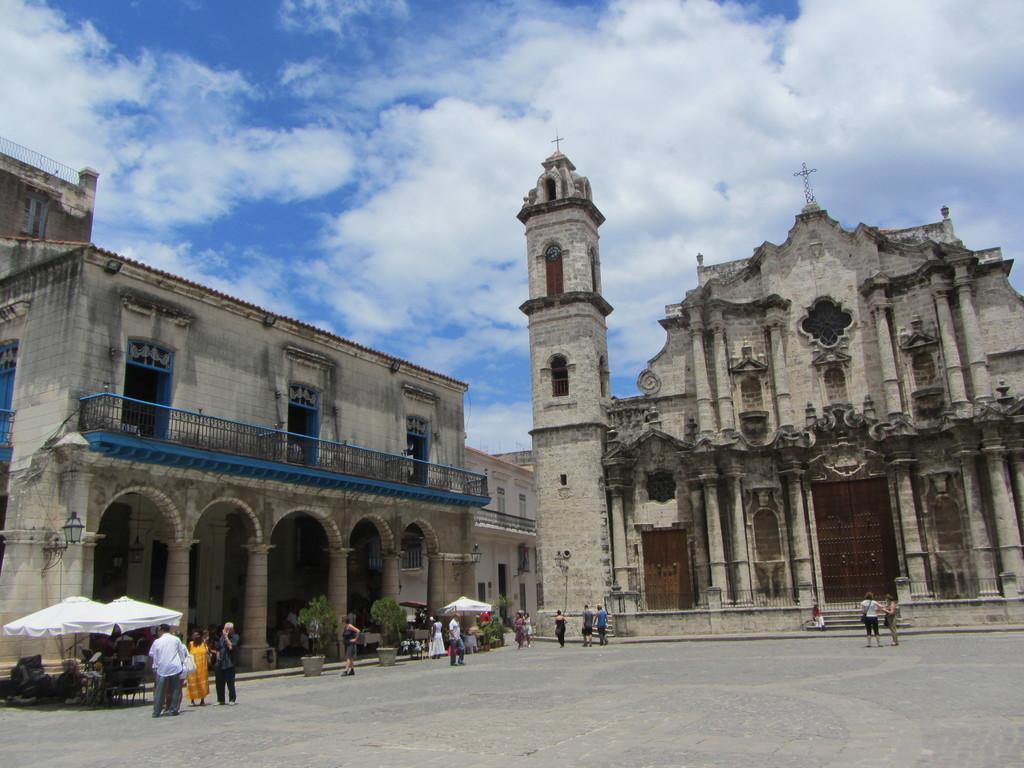How would you summarize this image in a sentence or two? There is a big church and beside the church there is a building,many people are visiting the church and there is a huge open land in front of the church. 